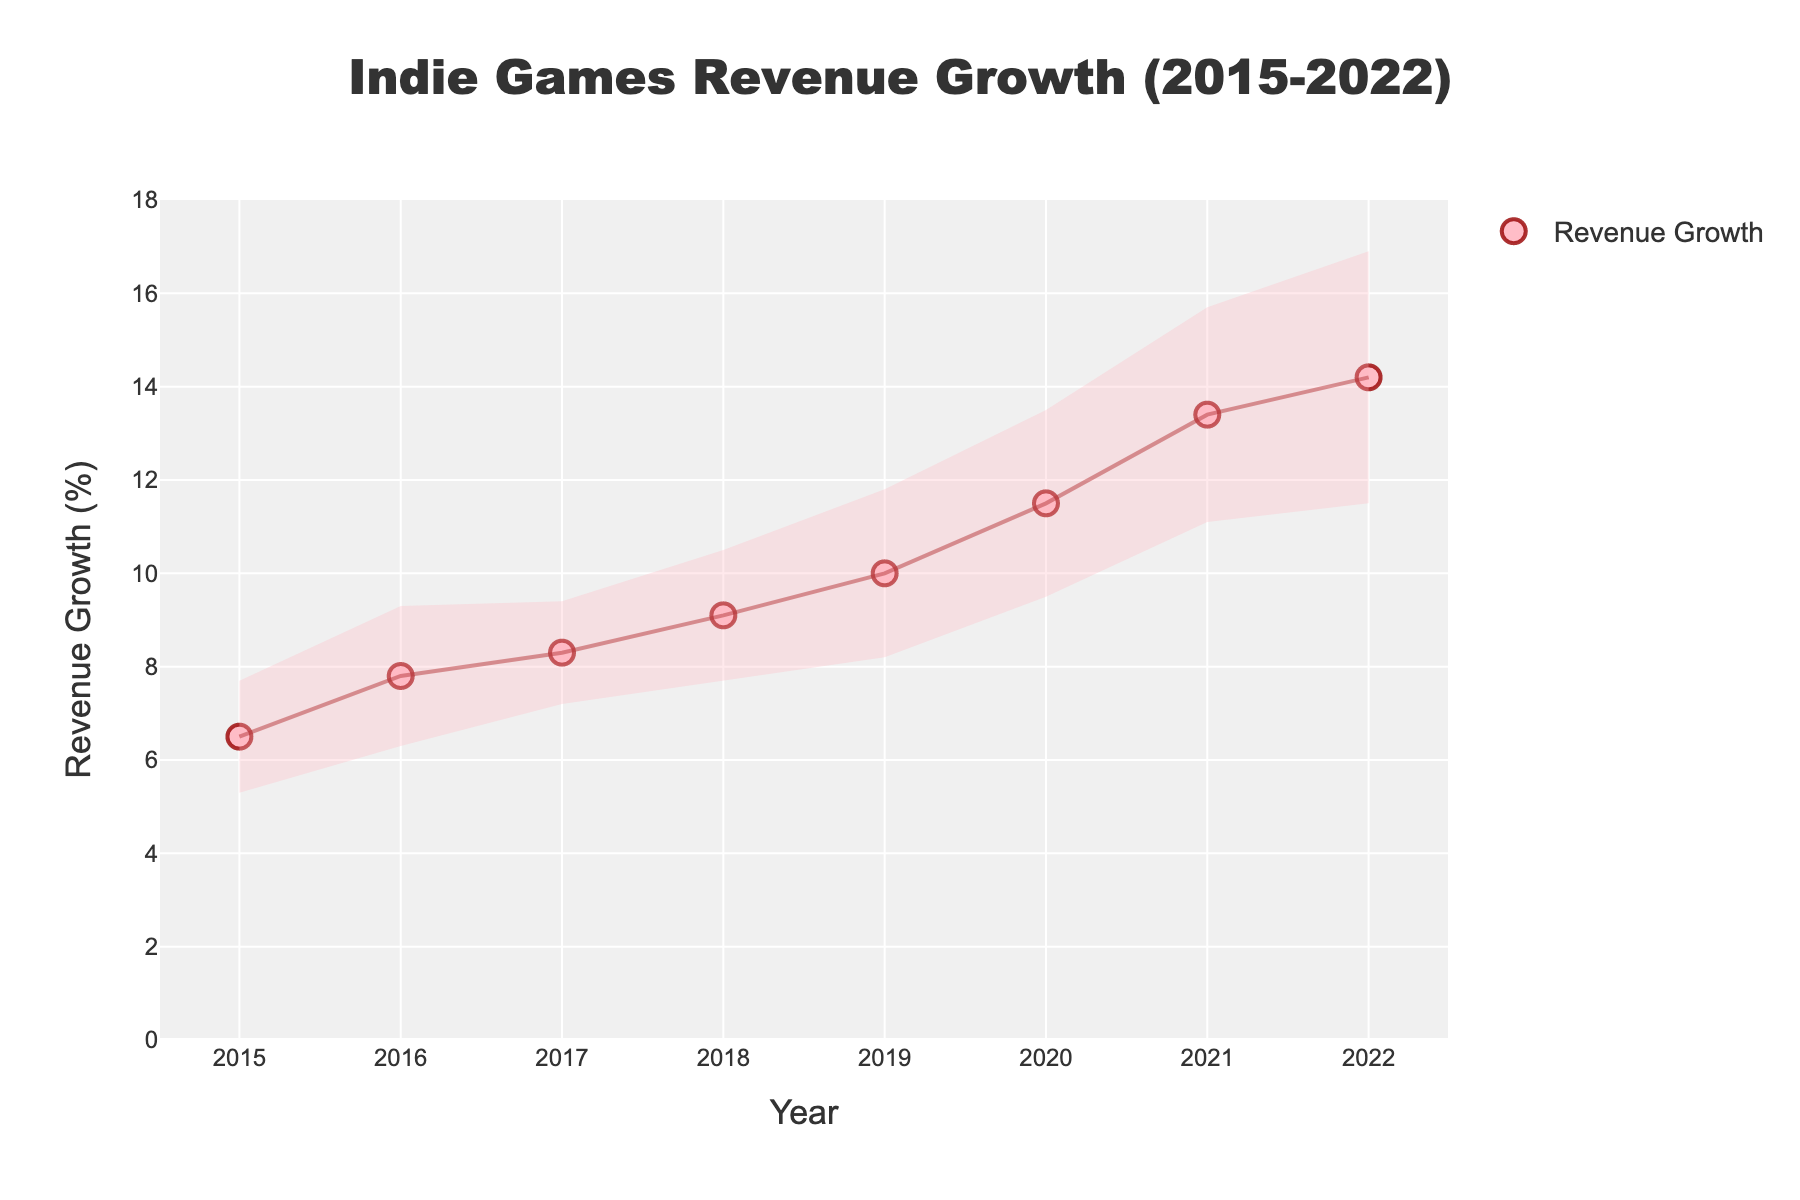what is the title of the figure? Look at the top center of the figure where the title is usually placed. The title of this figure is displayed at the top and reads "Indie Games Revenue Growth (2015-2022)".
Answer: Indie Games Revenue Growth (2015-2022) What is the average revenue growth for the years 2015 and 2016? Add the revenue growth for each year and then divide by the number of years. The revenue growth for 2015 is 6.5% and for 2016 is 7.8%. (6.5 + 7.8) / 2 = 7.15
Answer: 7.15% Which game had the highest revenue growth? Identify the game with the highest revenue growth percentage. Valheim in 2021 has the highest revenue growth at 13.4%.
Answer: Valheim What is the range of revenue growth seen within this period? Subtract the smallest revenue growth value from the largest revenue growth value. The smallest is 6.5% (2015) and the largest is 14.2% (2022). 14.2 - 6.5 = 7.7
Answer: 7.7% In which year did Celeste show revenue growth and what was its value? Find Celeste in the data and check its corresponding year and revenue growth. Celeste appeared in 2018 with a revenue growth of 9.1%.
Answer: 2018, 9.1% Which game had the largest standard deviation and what is its value? Look at the standard deviation column and locate the highest value. Cult of the Lamb in 2022 had the largest standard deviation at 2.7%.
Answer: Cult of the Lamb, 2.7% How does revenue growth for Hades (2020) compare to Hollow Knight (2017)? Check the revenue growth values for both Hades (11.5%) and Hollow Knight (8.3%). Hades had higher revenue growth than Hollow Knight.
Answer: Hades had higher revenue growth What are the upper and lower bounds of the revenue growth for Untitled Goose Game in 2019? Add the standard deviation to the revenue growth for the upper bound and subtract it for the lower bound. Revenue growth is 10.0% and standard deviation is 1.8. Upper bound: 10.0 + 1.8 = 11.8%. Lower bound: 10.0 - 1.8 = 8.2%.
Answer: 11.8%, 8.2% How many games had a revenue growth of over 10%? Count all data points with revenue growths over 10%. Games with over 10% revenue growth are: Hades (11.5%), Valheim (13.4%), and Cult of the Lamb (14.2%). That's three games in total.
Answer: 3 games 